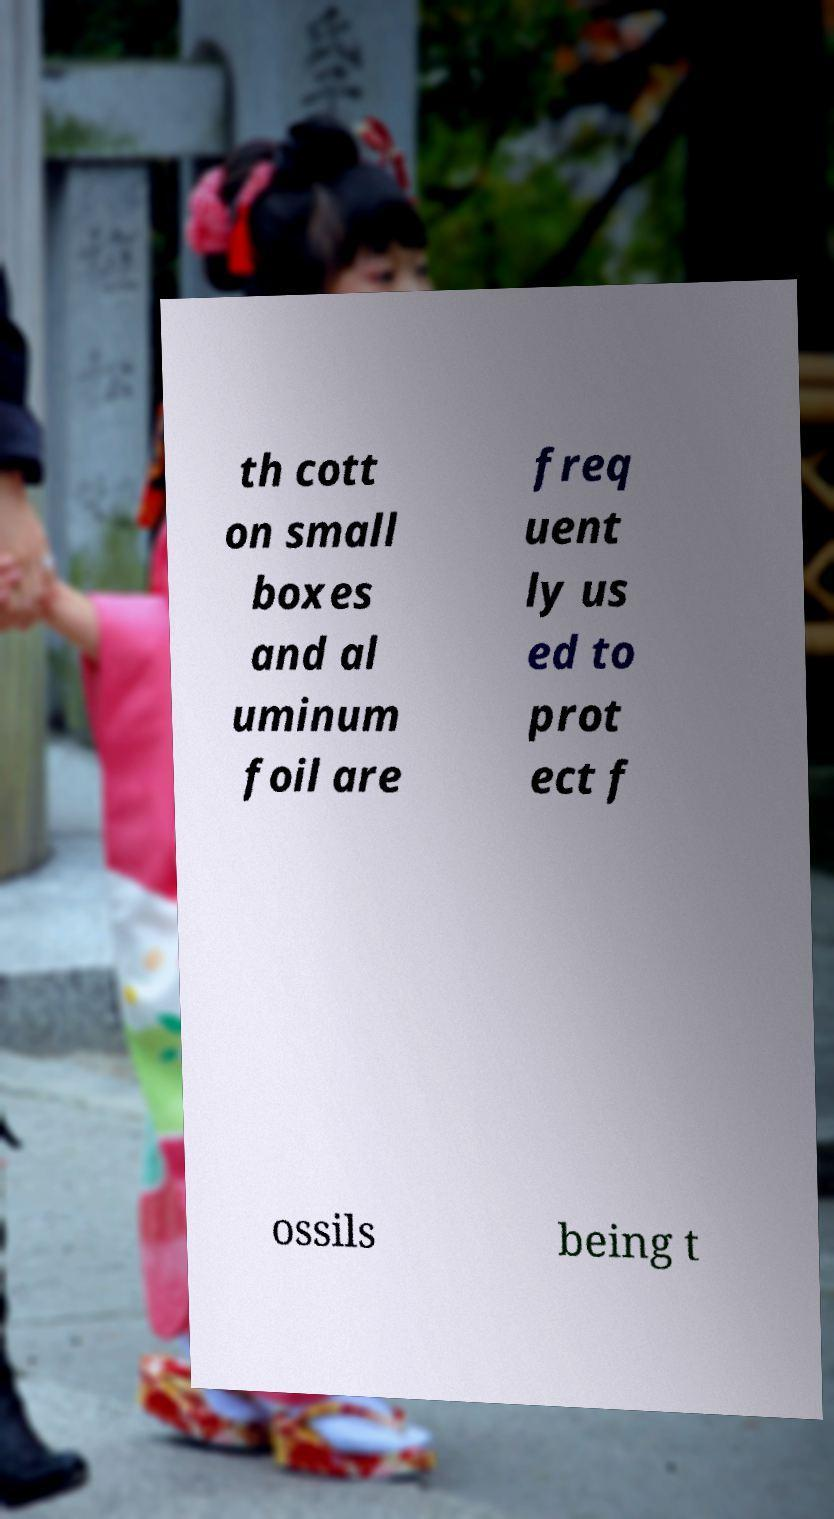For documentation purposes, I need the text within this image transcribed. Could you provide that? th cott on small boxes and al uminum foil are freq uent ly us ed to prot ect f ossils being t 